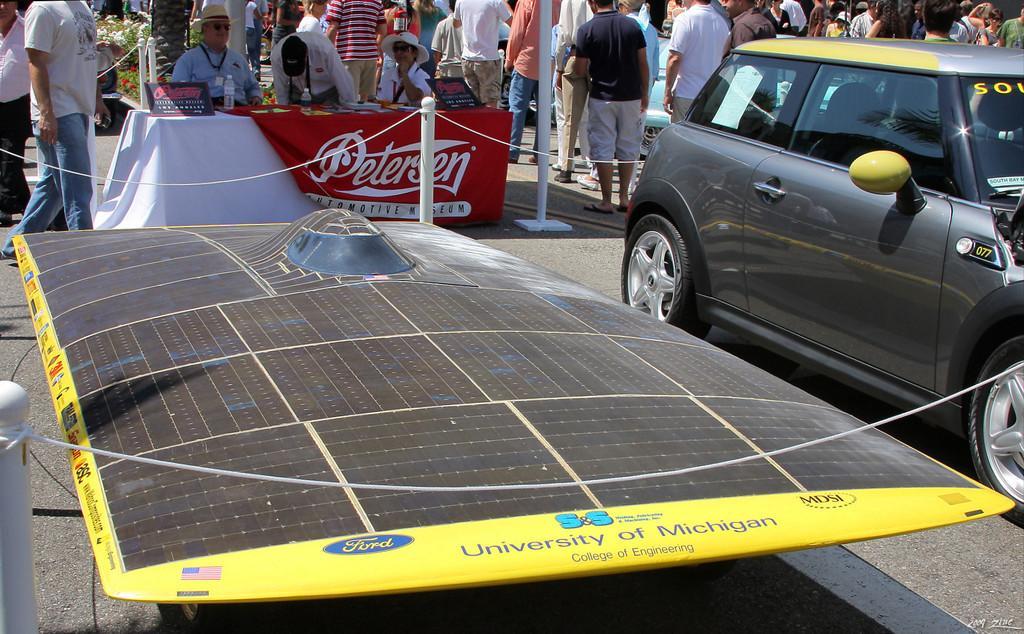Can you describe this image briefly? In this picture we can see car on the road, beside this car we can see an object. We can see ropes and poles. There are people and we can see boards, bottles and objects on the table, plants and flowers. 